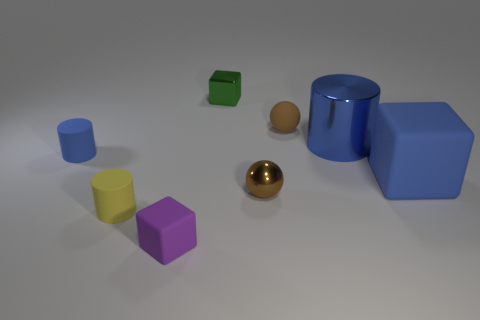Subtract all blue rubber cubes. How many cubes are left? 2 Subtract all green balls. How many blue cylinders are left? 2 Subtract 1 cubes. How many cubes are left? 2 Add 1 brown metal things. How many objects exist? 9 Subtract all yellow cylinders. How many cylinders are left? 2 Subtract all balls. How many objects are left? 6 Subtract 0 brown cylinders. How many objects are left? 8 Subtract all green cylinders. Subtract all cyan balls. How many cylinders are left? 3 Subtract all tiny shiny balls. Subtract all tiny blue rubber cylinders. How many objects are left? 6 Add 2 matte balls. How many matte balls are left? 3 